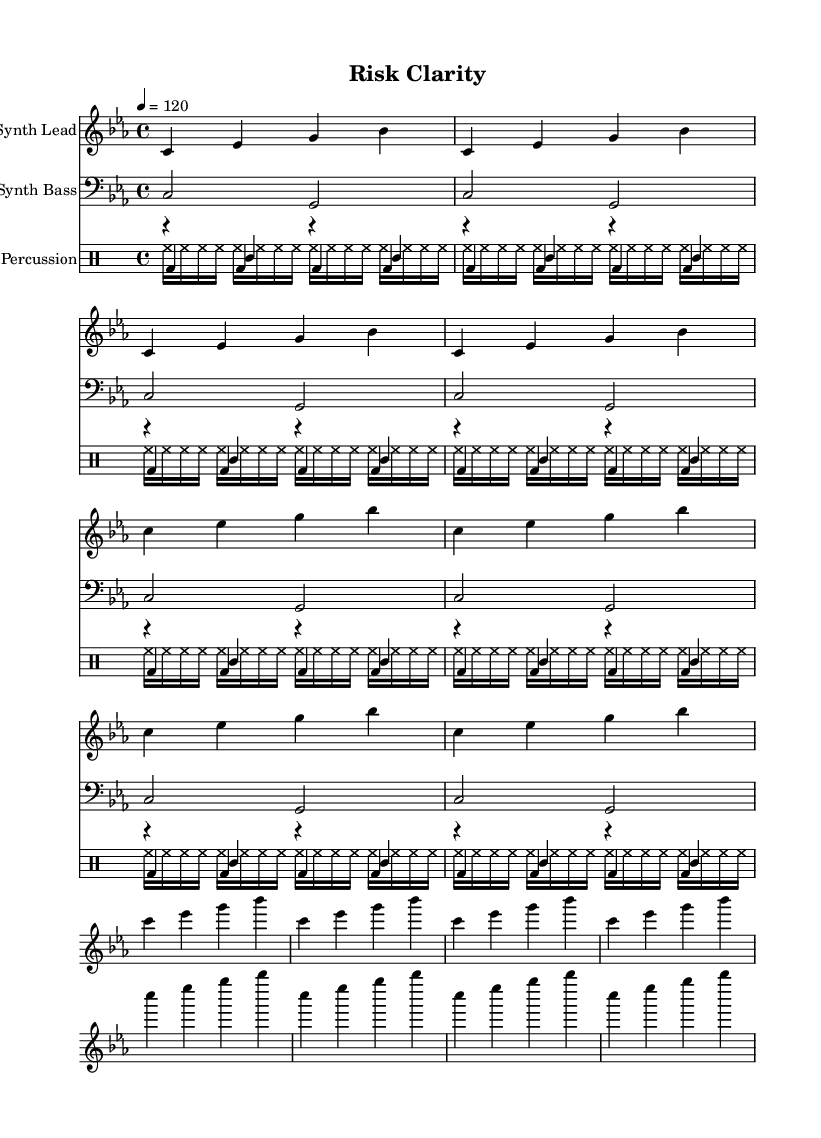What is the key signature of this music? The key signature is C minor, which is indicated by the three flat symbols in the staff.
Answer: C minor What is the time signature of this composition? The time signature is 4/4, which means there are four beats in each measure and a quarter note gets one beat. This is indicated at the beginning of the score.
Answer: 4/4 What is the tempo marking for this piece? The tempo marking indicates that the piece should be played at 120 beats per minute, which provides a moderate pace suitable for focus.
Answer: 120 How many measures are repeated for the Synth Lead? The Synth Lead section contains a repeated phrase that is played a total of 12 times, broken into groups of four measures each.
Answer: 12 Which instrument plays the bass line? The bass line is specified to be played by the Synth Bass, which is clearly labeled in the score.
Answer: Synth Bass What does the kick drum play in each measure? The kick drum plays a steady pattern of four quarter notes in every measure, indicating a solid, driving beat typical in minimalist techno.
Answer: Four quarter notes How does the hi-hat pattern contribute to the overall texture? The hi-hat plays sixteenth notes throughout each measure, creating a dense rhythmic texture that contrasts with the quarter notes of the kick drum.
Answer: Dense rhythmic texture 